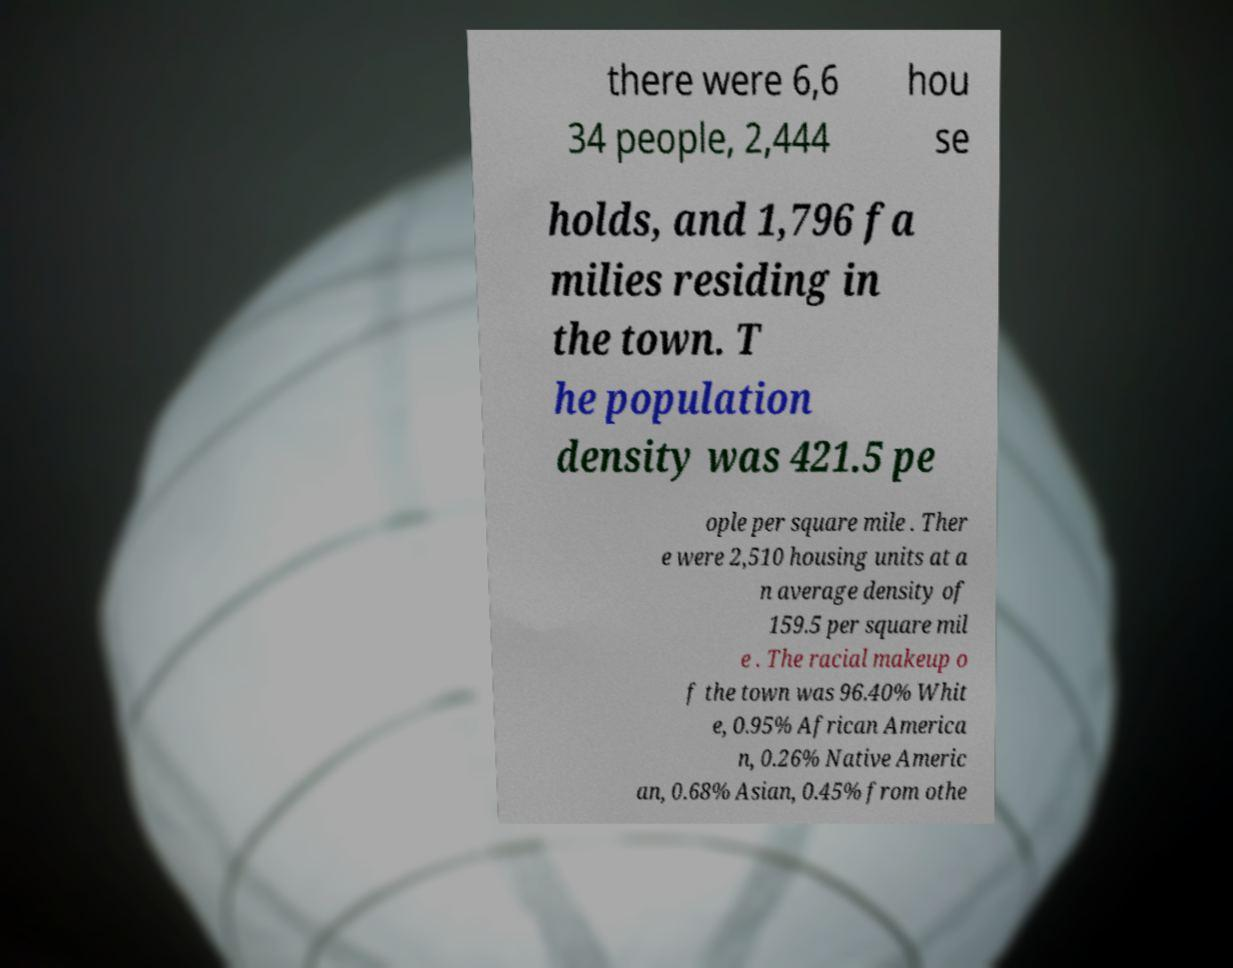Could you assist in decoding the text presented in this image and type it out clearly? there were 6,6 34 people, 2,444 hou se holds, and 1,796 fa milies residing in the town. T he population density was 421.5 pe ople per square mile . Ther e were 2,510 housing units at a n average density of 159.5 per square mil e . The racial makeup o f the town was 96.40% Whit e, 0.95% African America n, 0.26% Native Americ an, 0.68% Asian, 0.45% from othe 